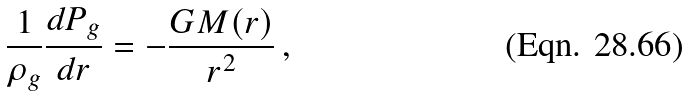Convert formula to latex. <formula><loc_0><loc_0><loc_500><loc_500>\frac { 1 } { \rho _ { g } } \frac { d P _ { g } } { d r } = - \frac { G M ( r ) } { r ^ { 2 } } \, ,</formula> 